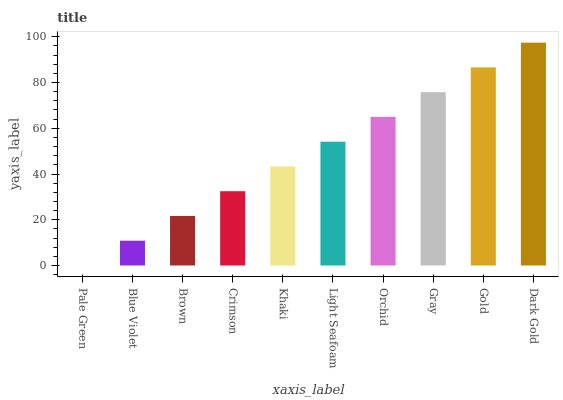Is Pale Green the minimum?
Answer yes or no. Yes. Is Dark Gold the maximum?
Answer yes or no. Yes. Is Blue Violet the minimum?
Answer yes or no. No. Is Blue Violet the maximum?
Answer yes or no. No. Is Blue Violet greater than Pale Green?
Answer yes or no. Yes. Is Pale Green less than Blue Violet?
Answer yes or no. Yes. Is Pale Green greater than Blue Violet?
Answer yes or no. No. Is Blue Violet less than Pale Green?
Answer yes or no. No. Is Light Seafoam the high median?
Answer yes or no. Yes. Is Khaki the low median?
Answer yes or no. Yes. Is Gray the high median?
Answer yes or no. No. Is Pale Green the low median?
Answer yes or no. No. 